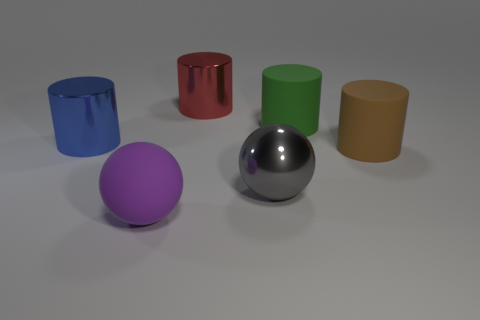Add 1 blue cylinders. How many objects exist? 7 Subtract all balls. How many objects are left? 4 Add 1 blue cylinders. How many blue cylinders are left? 2 Add 1 big gray objects. How many big gray objects exist? 2 Subtract 0 yellow balls. How many objects are left? 6 Subtract all small yellow metal cylinders. Subtract all large blue metallic objects. How many objects are left? 5 